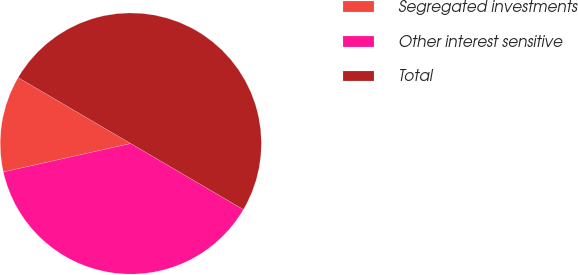<chart> <loc_0><loc_0><loc_500><loc_500><pie_chart><fcel>Segregated investments<fcel>Other interest sensitive<fcel>Total<nl><fcel>11.93%<fcel>38.07%<fcel>50.0%<nl></chart> 